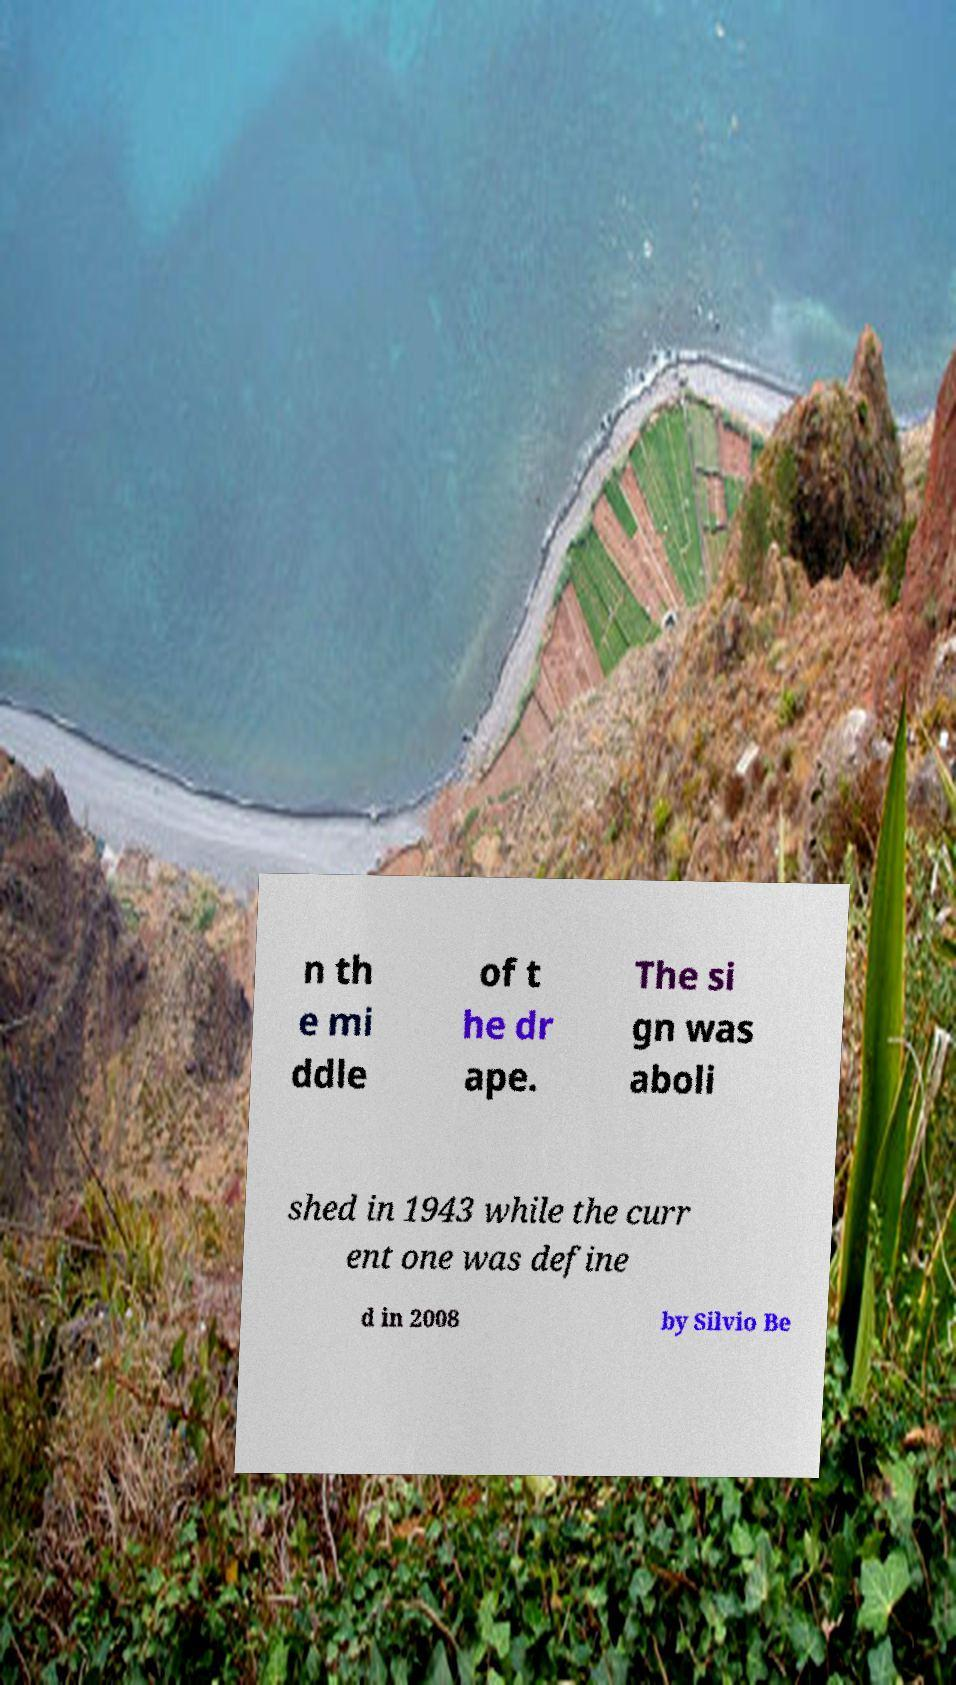Could you extract and type out the text from this image? n th e mi ddle of t he dr ape. The si gn was aboli shed in 1943 while the curr ent one was define d in 2008 by Silvio Be 